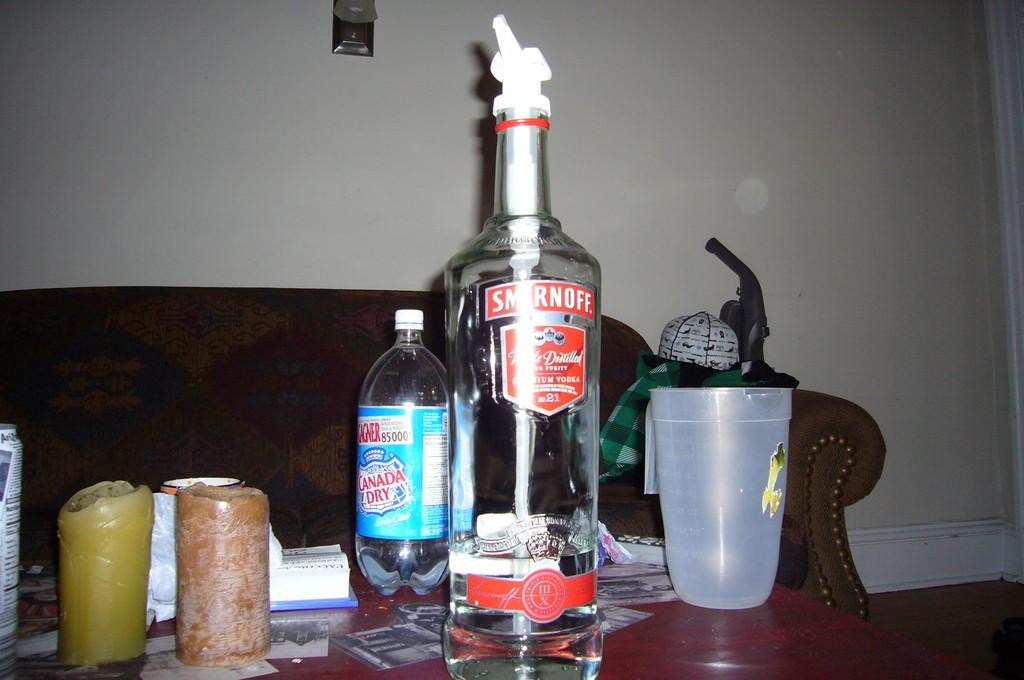What are the main objects in the center of the image? There is a vodka bottle, a water bottle, and a glass in the center of the image. Are there any other objects in the center of the image? Yes, there are additional objects in the center of the image. What can be seen in the background of the image? There is a couch and a wall in the background of the image. How many cherries are on the cloth in the image? There are no cherries or cloth present in the image. 